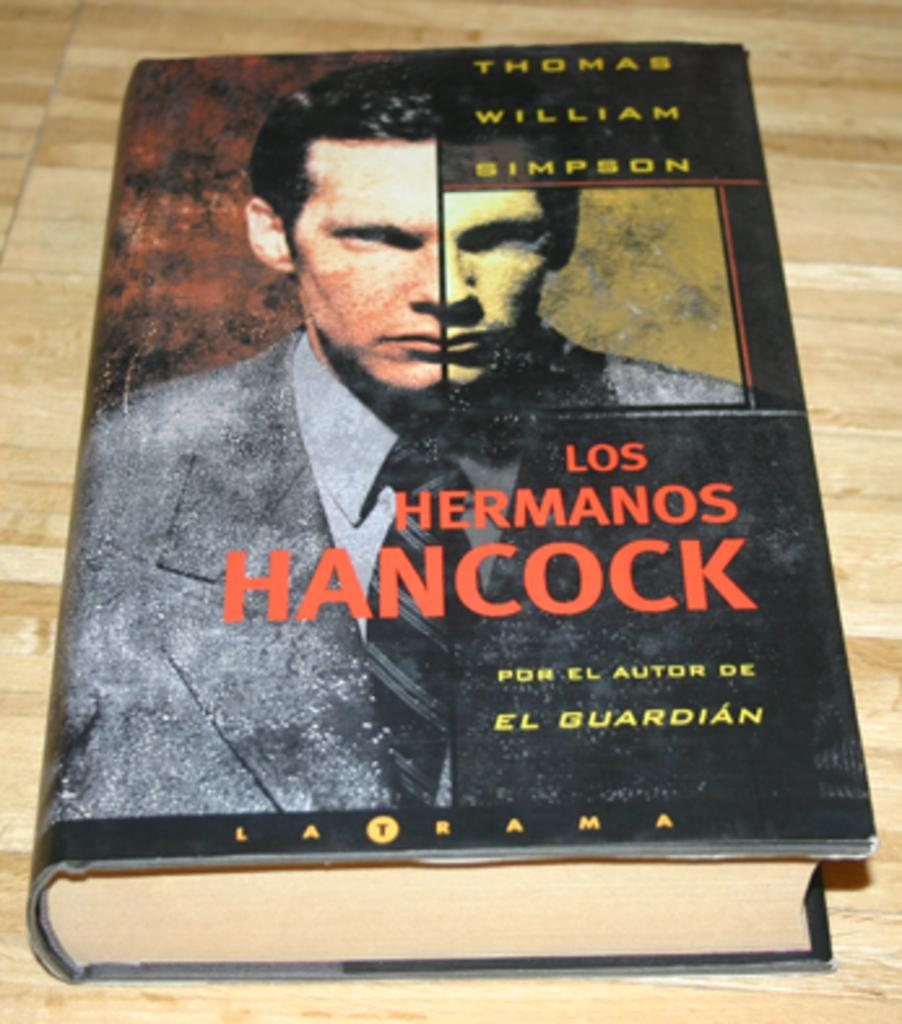Provide a one-sentence caption for the provided image. Los Hermanos Hancock chapter book by Thomas William Simpson. 